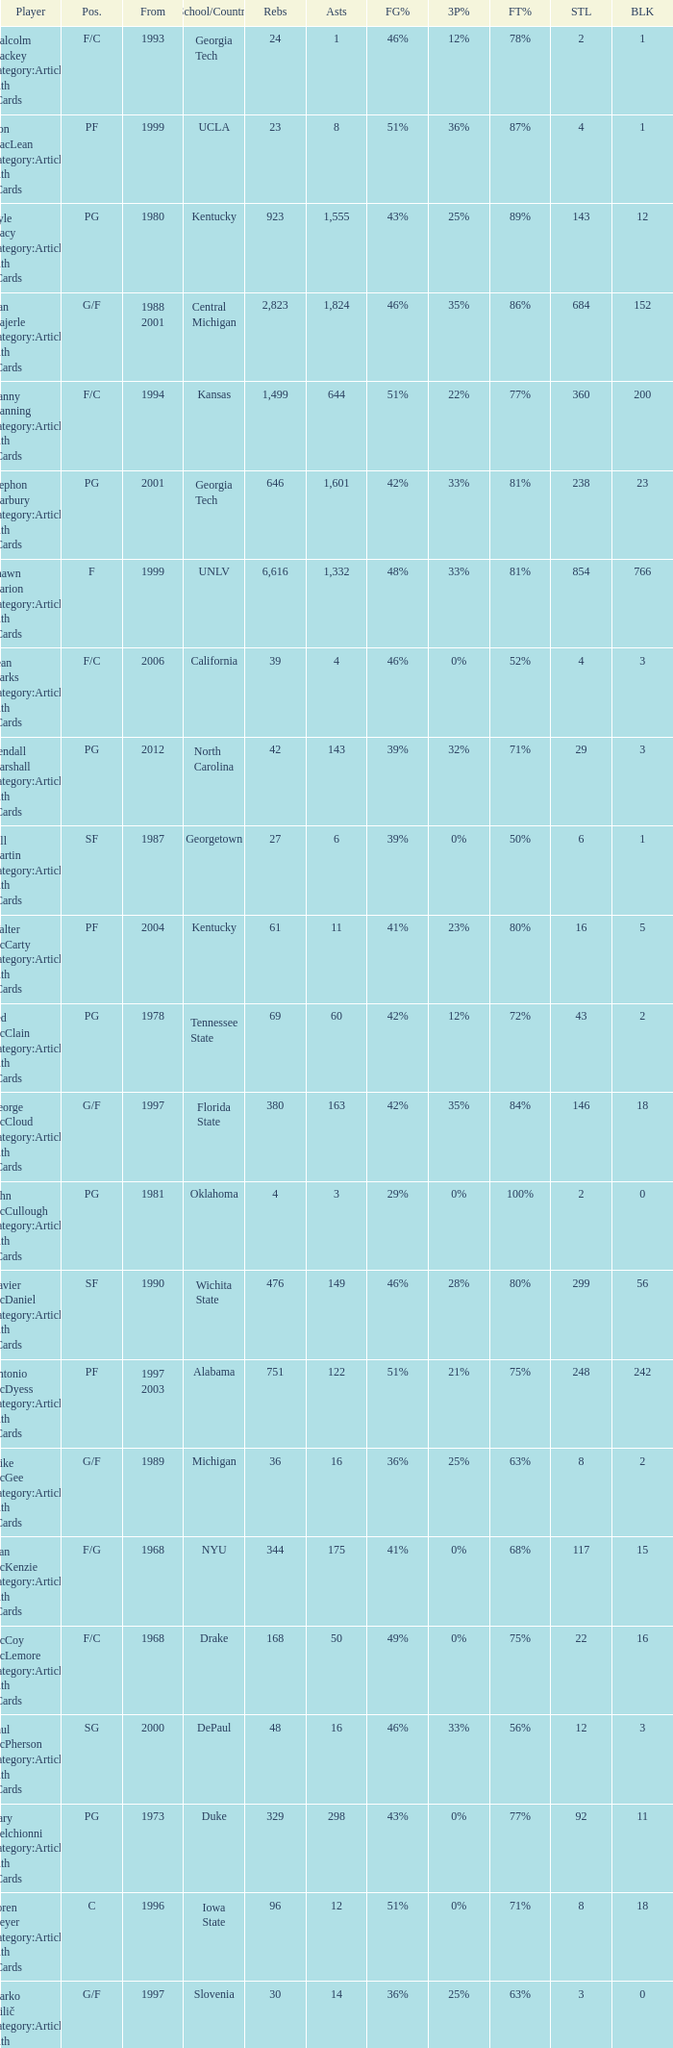What position does the player from arkansas play? C. 